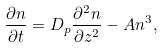<formula> <loc_0><loc_0><loc_500><loc_500>\frac { \partial n } { \partial t } = D _ { p } \frac { \partial ^ { 2 } n } { \partial z ^ { 2 } } - A n ^ { 3 } ,</formula> 